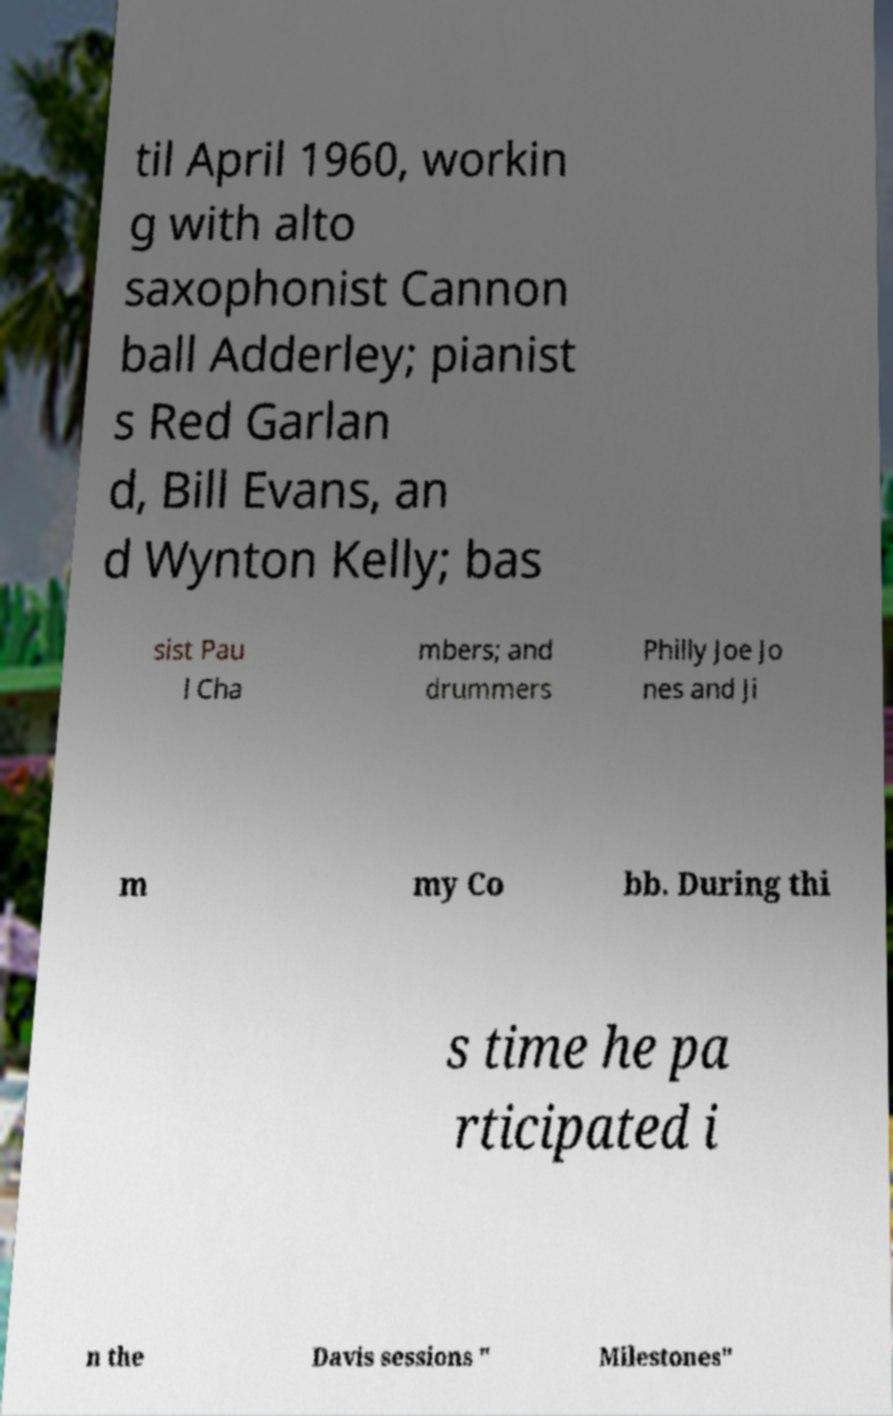Please identify and transcribe the text found in this image. til April 1960, workin g with alto saxophonist Cannon ball Adderley; pianist s Red Garlan d, Bill Evans, an d Wynton Kelly; bas sist Pau l Cha mbers; and drummers Philly Joe Jo nes and Ji m my Co bb. During thi s time he pa rticipated i n the Davis sessions " Milestones" 